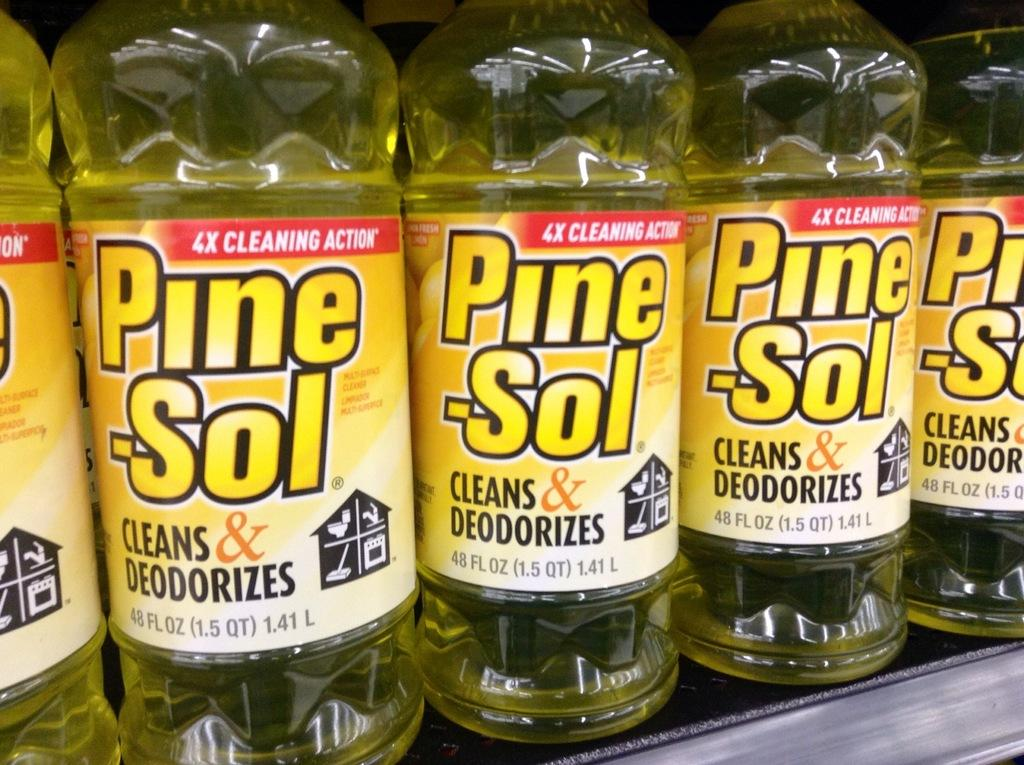Provide a one-sentence caption for the provided image. Several bottles of Pine-Sol lined up on a shelf. 